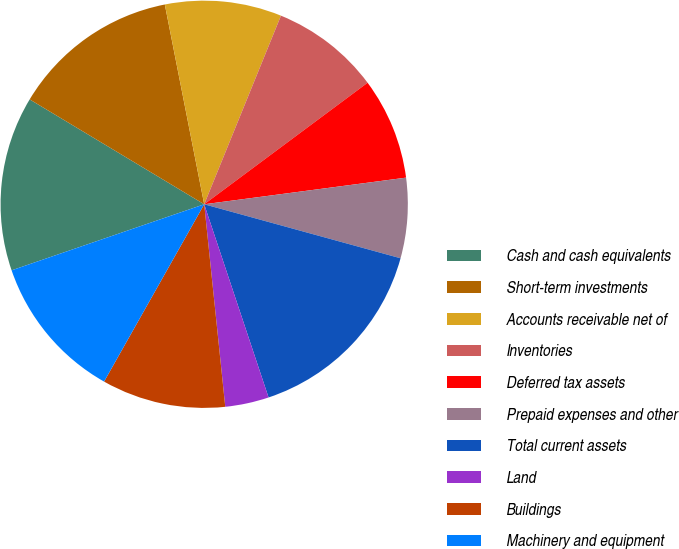<chart> <loc_0><loc_0><loc_500><loc_500><pie_chart><fcel>Cash and cash equivalents<fcel>Short-term investments<fcel>Accounts receivable net of<fcel>Inventories<fcel>Deferred tax assets<fcel>Prepaid expenses and other<fcel>Total current assets<fcel>Land<fcel>Buildings<fcel>Machinery and equipment<nl><fcel>13.87%<fcel>13.29%<fcel>9.25%<fcel>8.67%<fcel>8.09%<fcel>6.36%<fcel>15.61%<fcel>3.47%<fcel>9.83%<fcel>11.56%<nl></chart> 